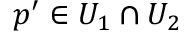Convert formula to latex. <formula><loc_0><loc_0><loc_500><loc_500>p ^ { \prime } \in U _ { 1 } \cap U _ { 2 }</formula> 